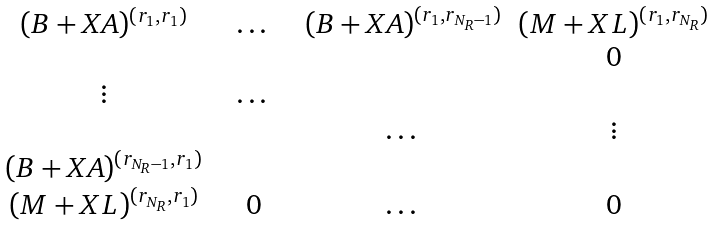Convert formula to latex. <formula><loc_0><loc_0><loc_500><loc_500>\begin{matrix} ( B + X A ) ^ { ( r _ { 1 } , r _ { 1 } ) } & & \dots & & ( B + X A ) ^ { ( r _ { 1 } , r _ { N _ { R } - 1 } ) } & ( M + X L ) ^ { ( r _ { 1 } , r _ { N _ { R } } ) } \\ & & & & & 0 \\ \vdots & & \dots & & & \\ & & & & \dots & \vdots \\ ( B + X A ) ^ { ( r _ { N _ { R } - 1 } , r _ { 1 } ) } & & & & & \\ ( M + X L ) ^ { ( r _ { N _ { R } } , r _ { 1 } ) } & & 0 & & \dots & 0 \end{matrix}</formula> 